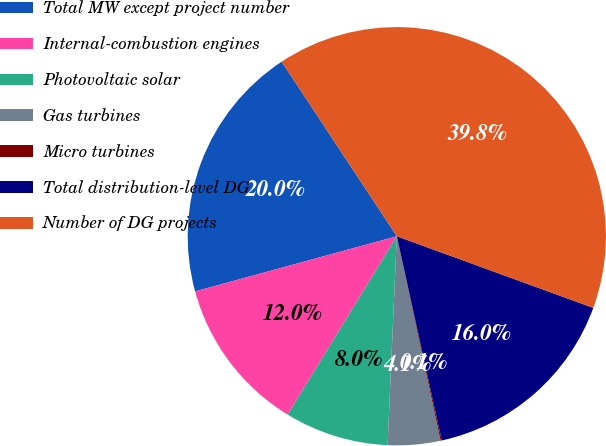Convert chart to OTSL. <chart><loc_0><loc_0><loc_500><loc_500><pie_chart><fcel>Total MW except project number<fcel>Internal-combustion engines<fcel>Photovoltaic solar<fcel>Gas turbines<fcel>Micro turbines<fcel>Total distribution-level DG<fcel>Number of DG projects<nl><fcel>19.97%<fcel>12.01%<fcel>8.04%<fcel>4.06%<fcel>0.09%<fcel>15.99%<fcel>39.85%<nl></chart> 